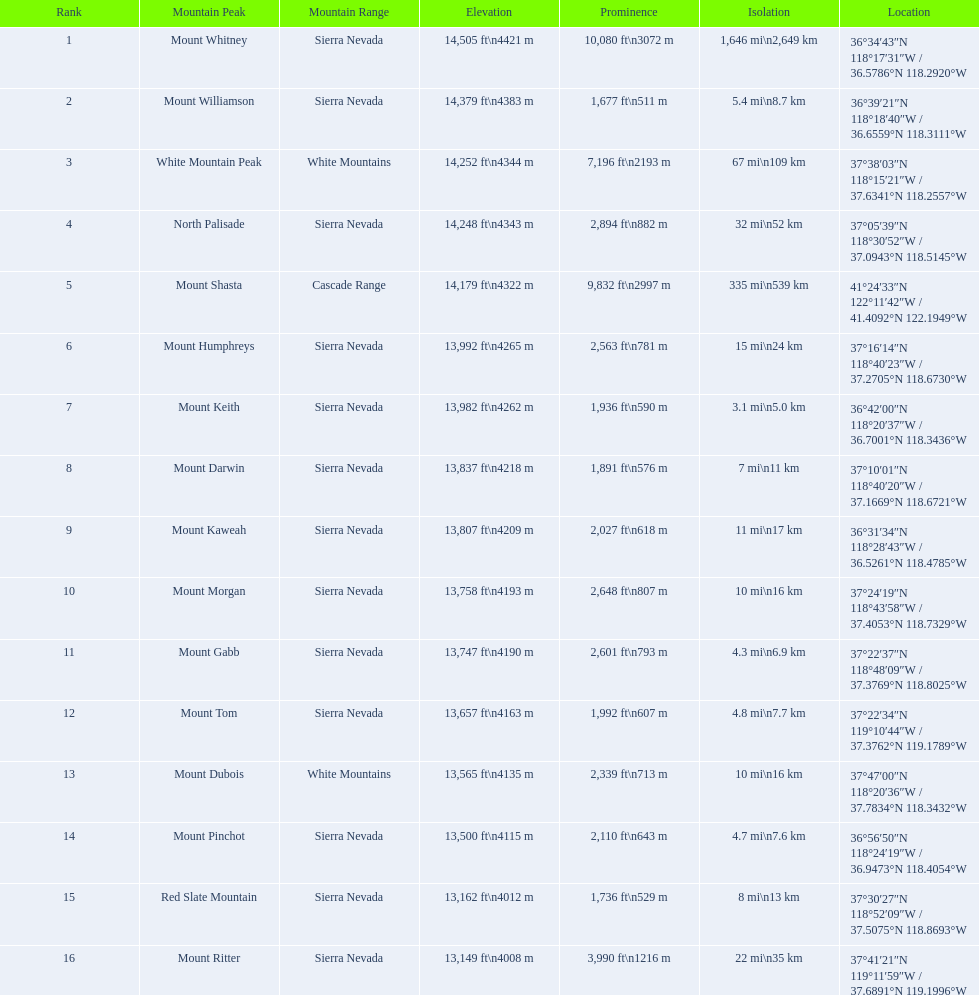Which mountain peaks have a prominence over 9,000 ft? Mount Whitney, Mount Shasta. Of those, which one has the the highest prominence? Mount Whitney. 